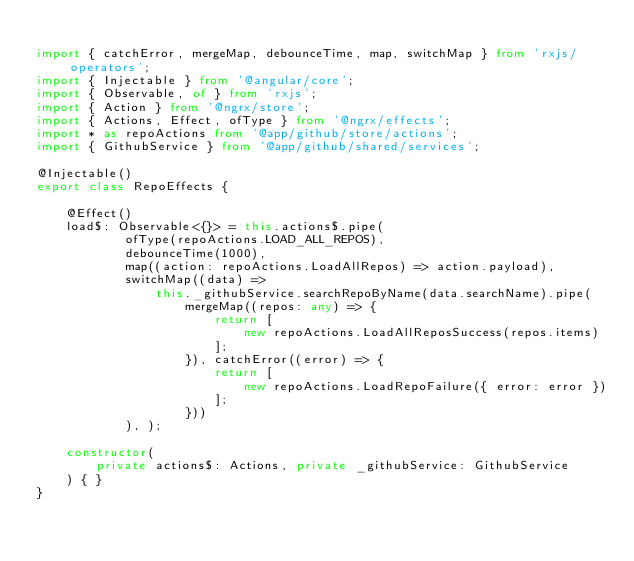Convert code to text. <code><loc_0><loc_0><loc_500><loc_500><_TypeScript_>
import { catchError, mergeMap, debounceTime, map, switchMap } from 'rxjs/operators';
import { Injectable } from '@angular/core';
import { Observable, of } from 'rxjs';
import { Action } from '@ngrx/store';
import { Actions, Effect, ofType } from '@ngrx/effects';
import * as repoActions from '@app/github/store/actions';
import { GithubService } from '@app/github/shared/services';

@Injectable()
export class RepoEffects {

    @Effect()
    load$: Observable<{}> = this.actions$.pipe(
            ofType(repoActions.LOAD_ALL_REPOS),
            debounceTime(1000),
            map((action: repoActions.LoadAllRepos) => action.payload),
            switchMap((data) =>
                this._githubService.searchRepoByName(data.searchName).pipe(
                    mergeMap((repos: any) => {
                        return [
                            new repoActions.LoadAllReposSuccess(repos.items)
                        ];
                    }), catchError((error) => {
                        return [
                            new repoActions.LoadRepoFailure({ error: error })
                        ];
                    }))
            ), );

    constructor(
        private actions$: Actions, private _githubService: GithubService
    ) { }
}
</code> 